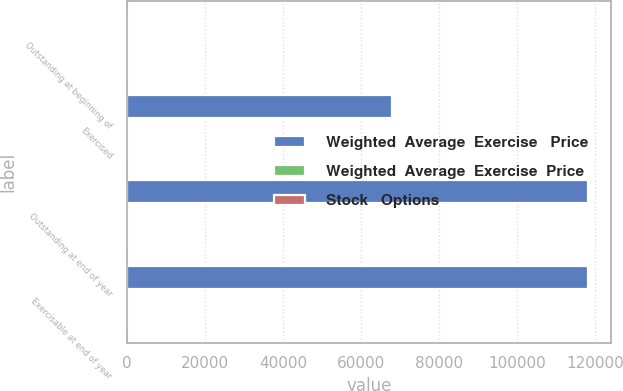Convert chart. <chart><loc_0><loc_0><loc_500><loc_500><stacked_bar_chart><ecel><fcel>Outstanding at beginning of<fcel>Exercised<fcel>Outstanding at end of year<fcel>Exercisable at end of year<nl><fcel>Weighted  Average  Exercise   Price<fcel>43.88<fcel>67829<fcel>118225<fcel>118225<nl><fcel>Weighted  Average  Exercise  Price<fcel>43.88<fcel>44.46<fcel>43.55<fcel>43.55<nl><fcel>Stock   Options<fcel>41.8<fcel>36.22<fcel>43.88<fcel>43.88<nl></chart> 